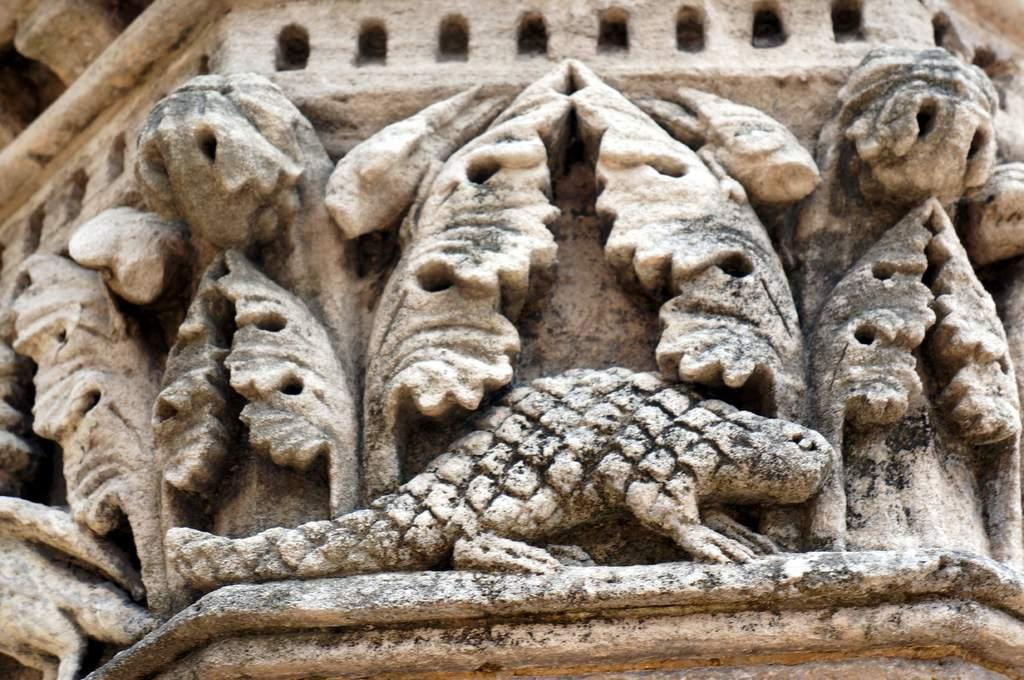What is present on the wall in the image? There are sculptures on the wall in the image. What type of receipt can be seen hanging from the sculpture in the image? There is no receipt present in the image; it only features sculptures on the wall. What color is the skirt worn by the heart in the image? There is no heart or skirt present in the image; it only features sculptures on the wall. 